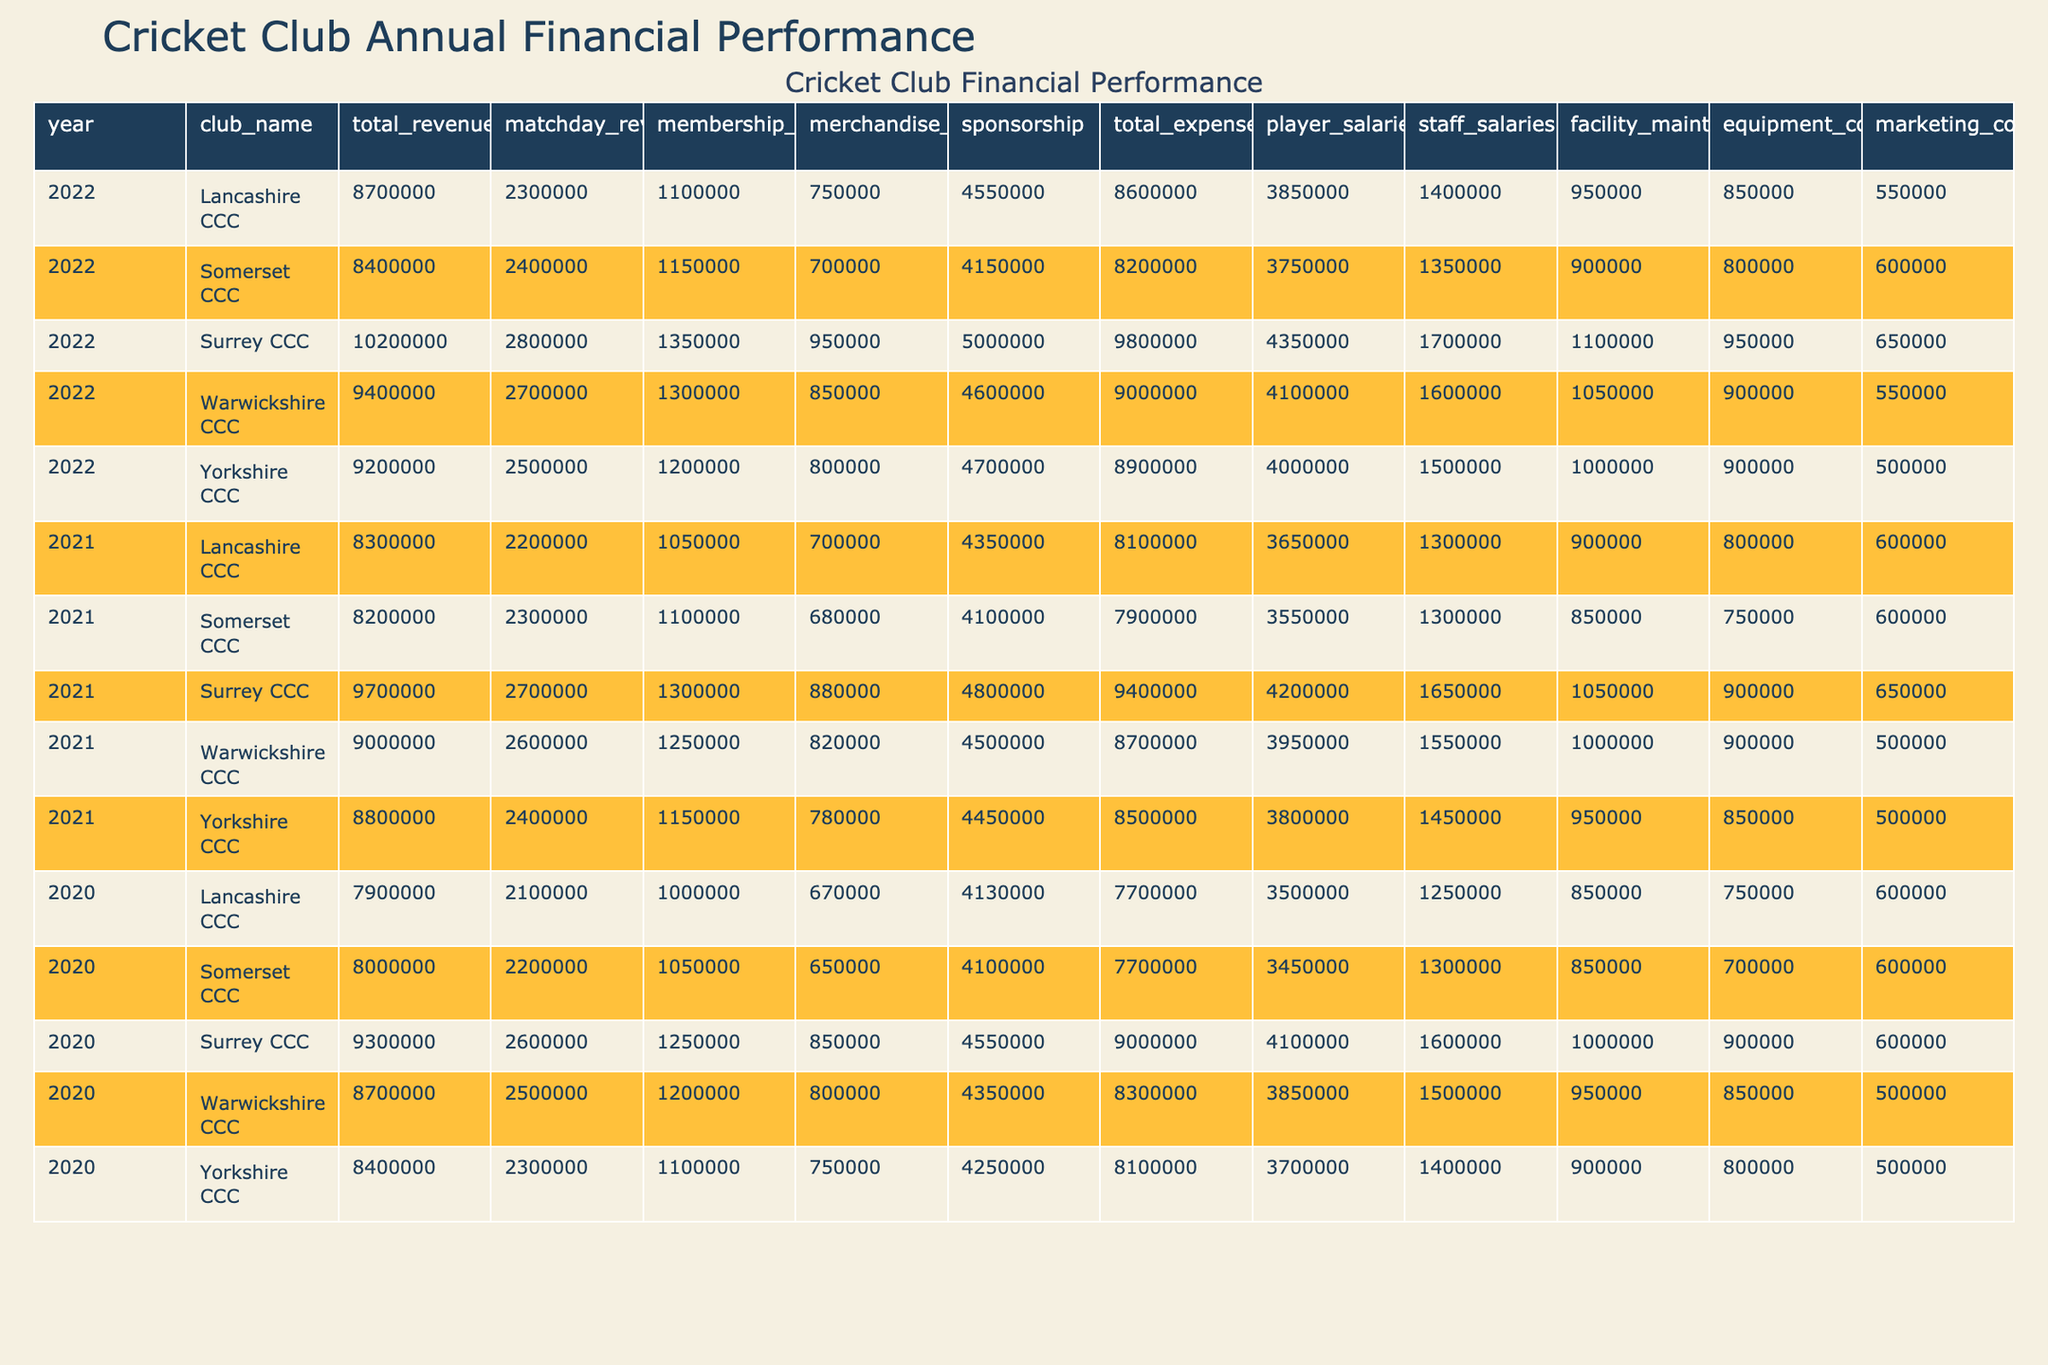What was the total revenue for Surrey CCC in 2022? The table indicates that for the year 2022, the total revenue for Surrey CCC is explicitly listed as 10,200,000.
Answer: 10,200,000 Which cricket club had the highest matchday revenue in 2021? Looking through the matchday revenues for 2021, Surrey CCC has 2,700,000, the highest among all clubs listed, compared to others.
Answer: Surrey CCC What is the difference in total expenses between Lancashire CCC in 2022 and 2021? The total expenses for Lancashire CCC in 2022 is 8,600,000 and in 2021 is 8,100,000. Subtracting gives 8,600,000 - 8,100,000 = 500,000.
Answer: 500,000 Did Warwickshire CCC increase or decrease its total revenue from 2021 to 2022? In 2021, Warwickshire CCC had a total revenue of 9,000,000, and in 2022, it increased to 9,400,000. Therefore, there was an increase in revenue.
Answer: Increase What was the average membership fee across all clubs in 2022? The membership fees for each club in 2022 are 1,200,000 (Yorkshire), 1,100,000 (Lancashire), 1,300,000 (Warwickshire), 1,350,000 (Surrey), and 1,150,000 (Somerset). Summing these values gives a total of 6,100,000. Dividing this by 5 gives an average membership fee of 1,220,000.
Answer: 1,220,000 Which cricket club has the lowest total revenue in 2020? Scanning the total revenue for each club in 2020, Somerset CCC has the lowest figure at 8,000,000 compared to the other clubs' revenues.
Answer: Somerset CCC What is the percentage increase in sponsorship from 2021 to 2022 for Yorkshire CCC? In 2021, Yorkshire CCC had sponsorship income of 4,450,000, which increased to 4,700,000 in 2022. The difference is 4,700,000 - 4,450,000 = 250,000. The percentage increase is (250,000 / 4,450,000) * 100 = approximately 5.62%.
Answer: Approximately 5.62% Was the total revenue for Somerset CCC higher in 2021 or 2022? Looking at the total revenues, Somerset CCC had 8,400,000 in 2021 and 8,400,000 in 2022. Since both values are the same, it has not changed.
Answer: Equal 